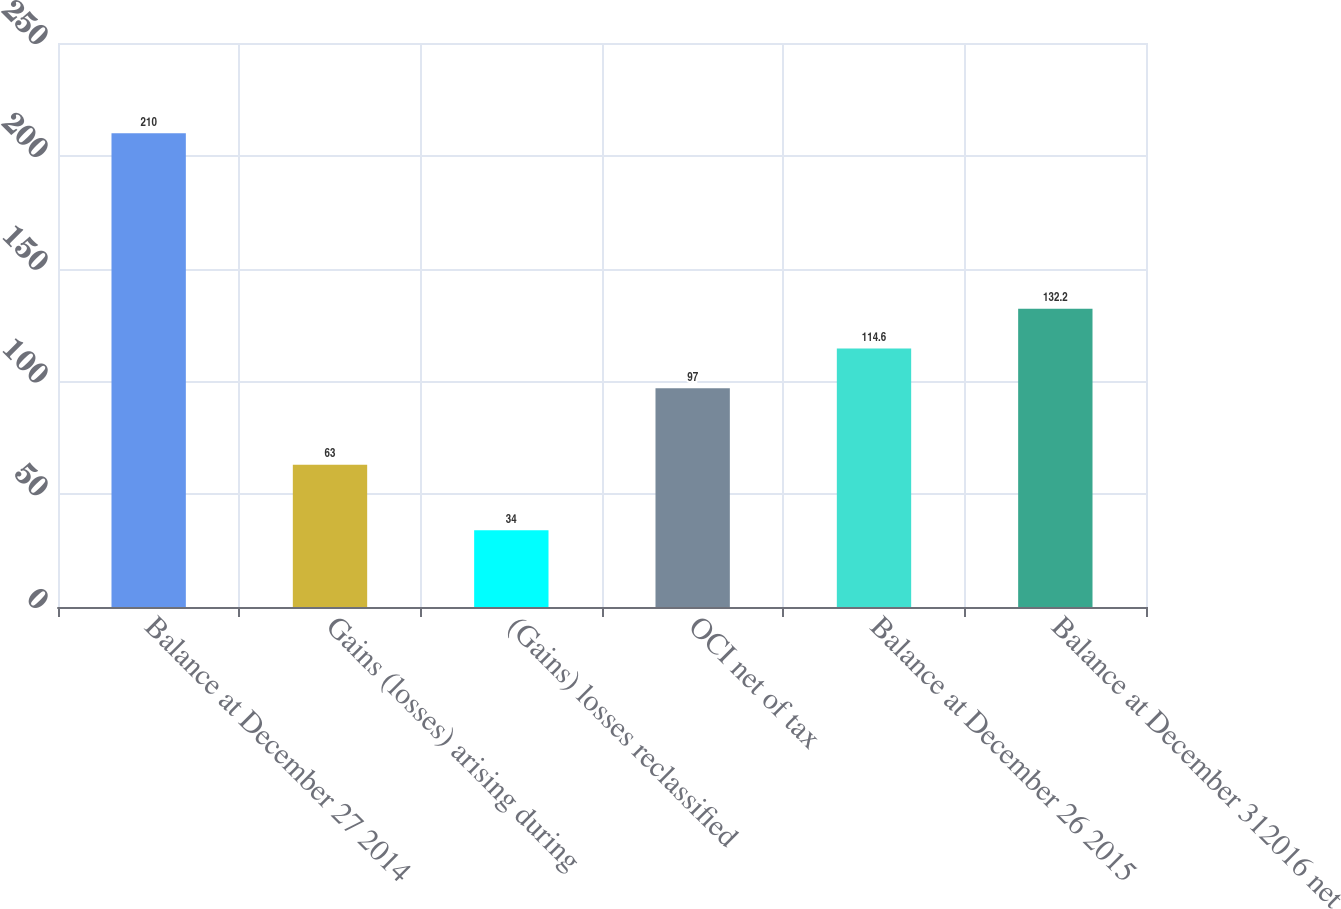Convert chart. <chart><loc_0><loc_0><loc_500><loc_500><bar_chart><fcel>Balance at December 27 2014<fcel>Gains (losses) arising during<fcel>(Gains) losses reclassified<fcel>OCI net of tax<fcel>Balance at December 26 2015<fcel>Balance at December 312016 net<nl><fcel>210<fcel>63<fcel>34<fcel>97<fcel>114.6<fcel>132.2<nl></chart> 